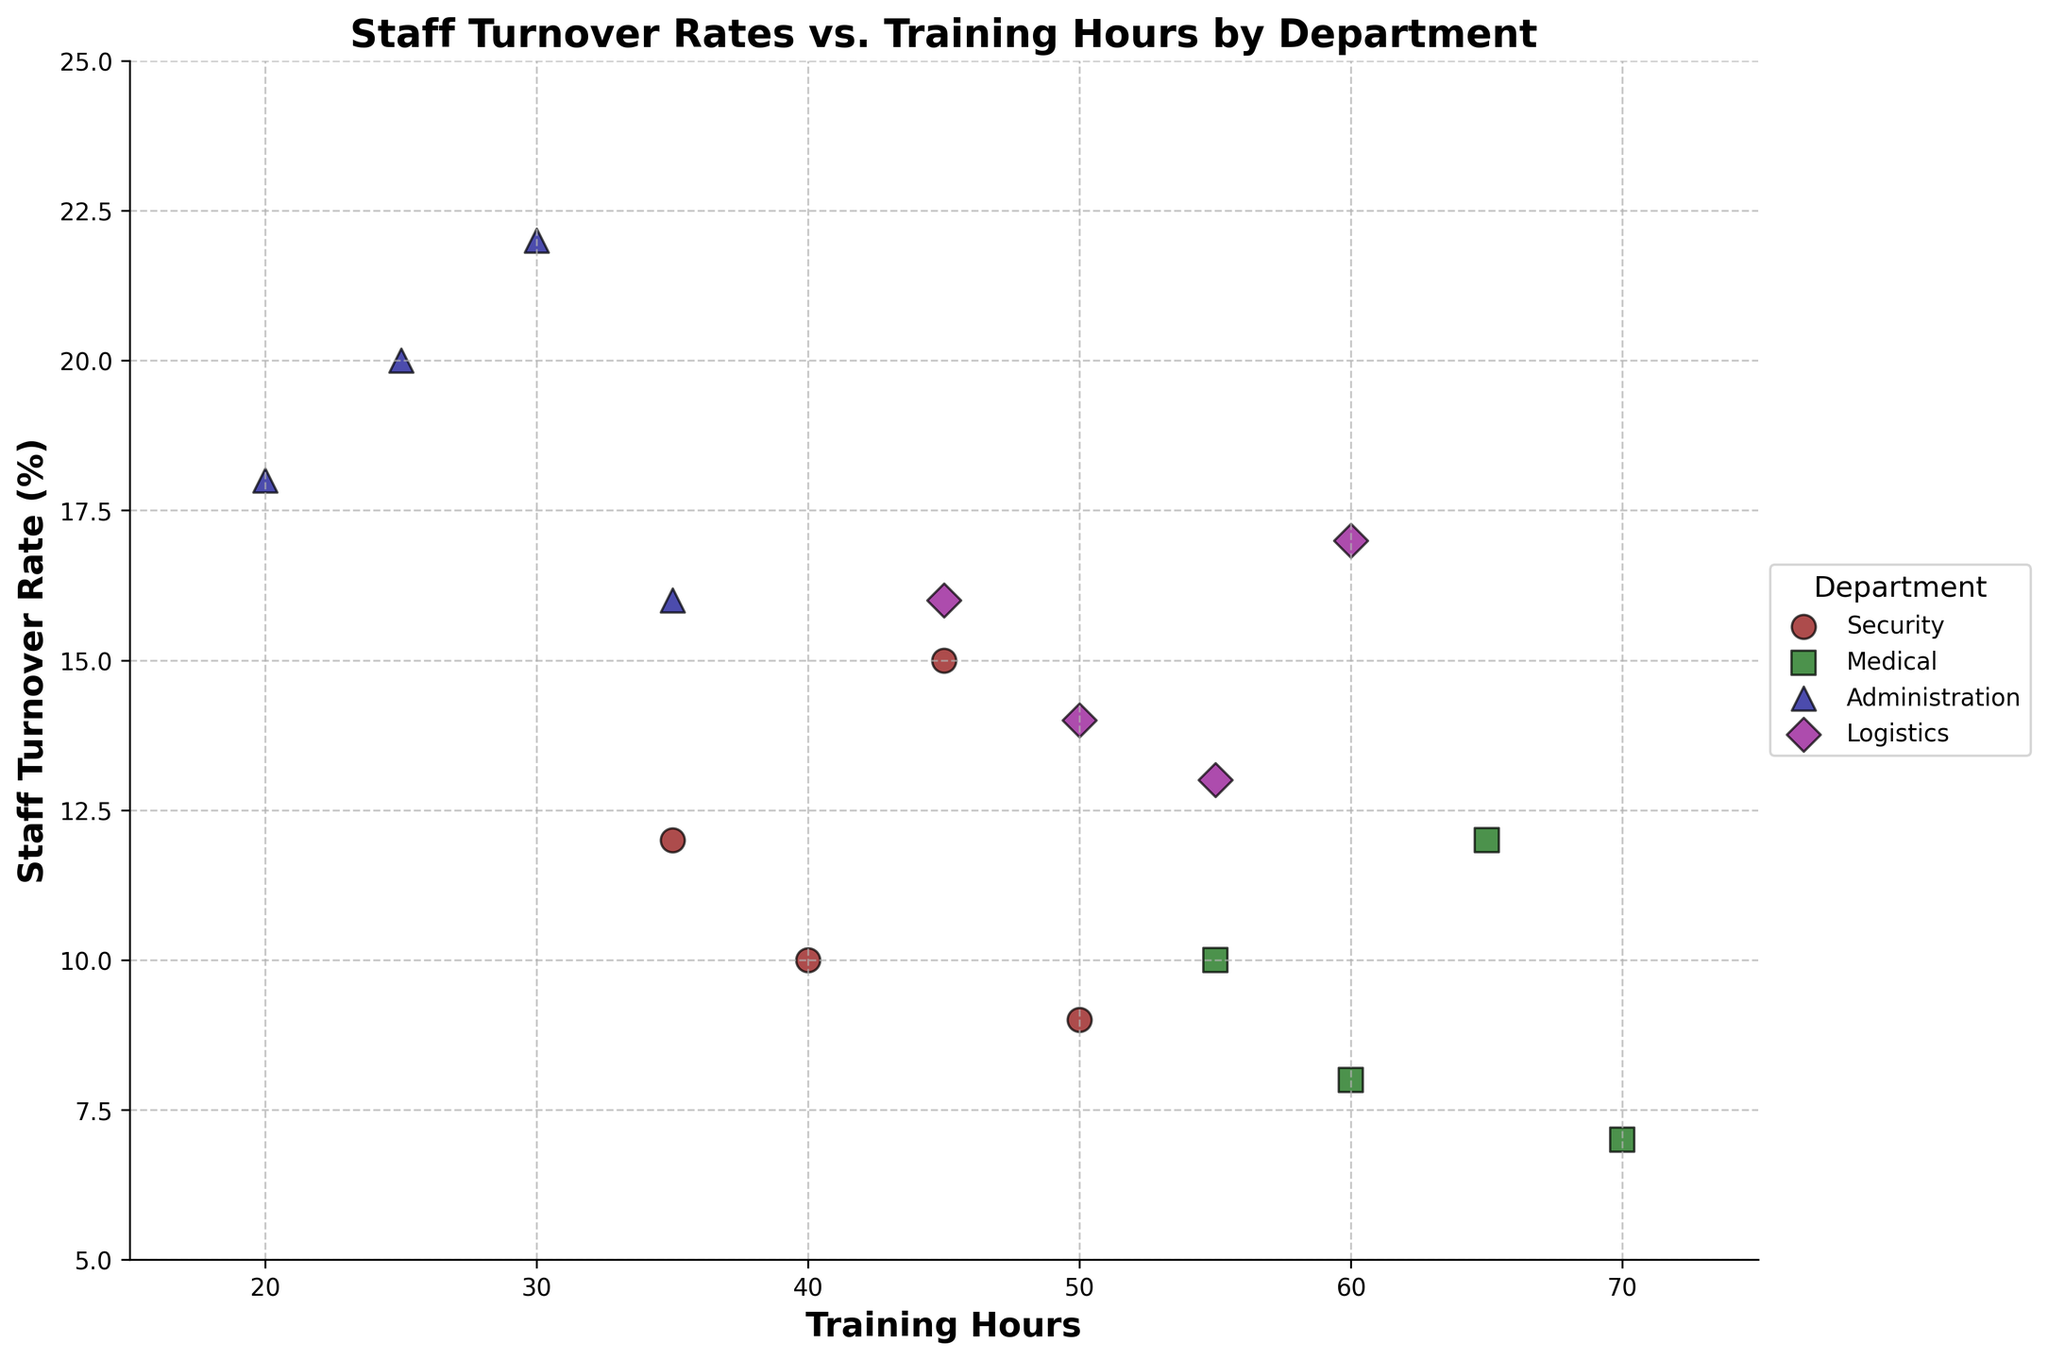What's the title of the plot? The title of the plot is mentioned at the top of the figure, providing a summary of the plot content.
Answer: Staff Turnover Rates vs. Training Hours by Department How many departments are depicted in the plot? The legend on the right side of the plot shows the different departments depicted in the figure.
Answer: 4 Which department has the most variations in training hours? By looking at the spread of the data points along the x-axis (Training Hours), we can observe which department's points are spread out the most.
Answer: Medical What is the lowest staff turnover rate in the Administration department? By looking at the y-axis values for the data points colored and marked for the Administration department, the lowest turnover rate can be observed.
Answer: 16% Which department appears to have the highest staff turnover rate and what is that rate? Checking the data points for each department on the y-axis, the highest rate can be identified.
Answer: Administration, 22% Compare the range of training hours for the Security and Logistics departments. Which has a wider range? By noting the minimum and maximum values of training hours on the x-axis for both departments, the difference in ranges can be determined.
Answer: Logistics What is the highest number of training hours recorded in the Medical department? Look at the x-axis values and find the maximum value for the Medical department data points.
Answer: 70 Which department shows the smallest variation in staff turnover rates, and what is the range of this variation? By examining the spread of data points along the y-axis for each department, the department with the smallest difference between highest and lowest rates can be identified.
Answer: Medical, range of 5% (7%-12%) Are there any departments where increased training hours consistently result in lower staff turnover rates? Analyze the trend of data points for each department to identify a negative correlation between training hours and staff turnover rates.
Answer: No, there are no clear trends where increased training hours consistently result in lower staff turnover rates Do any departments overlap significantly in their training hours and turnover rates? By observing the plot and checking for data points from different departments that are closely positioned, we can identify any significant overlap.
Answer: Yes, Security and Logistics overlap in the training hours range of 45-50 hours 